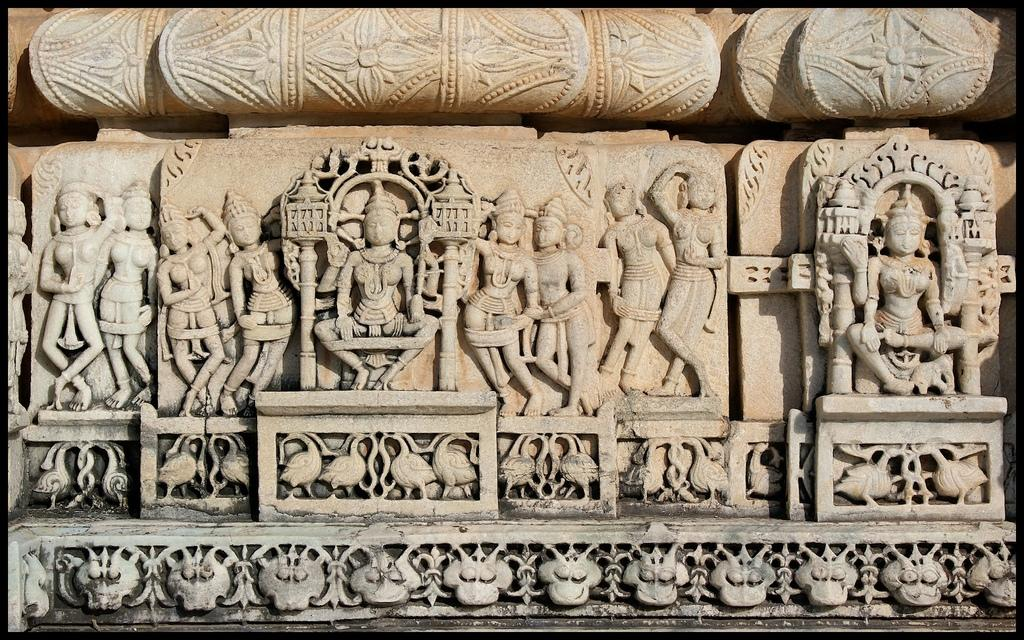What can be seen on the wall in the image? There are carvings on the wall in the image. What color is the wall in the image? The wall is in cream color. Is there any specific design or pattern on the wall in the image? Yes, there is a design on the wall at the bottom of the image. How many cubs are playing with a ticket in the image? There are no cubs or tickets present in the image. 